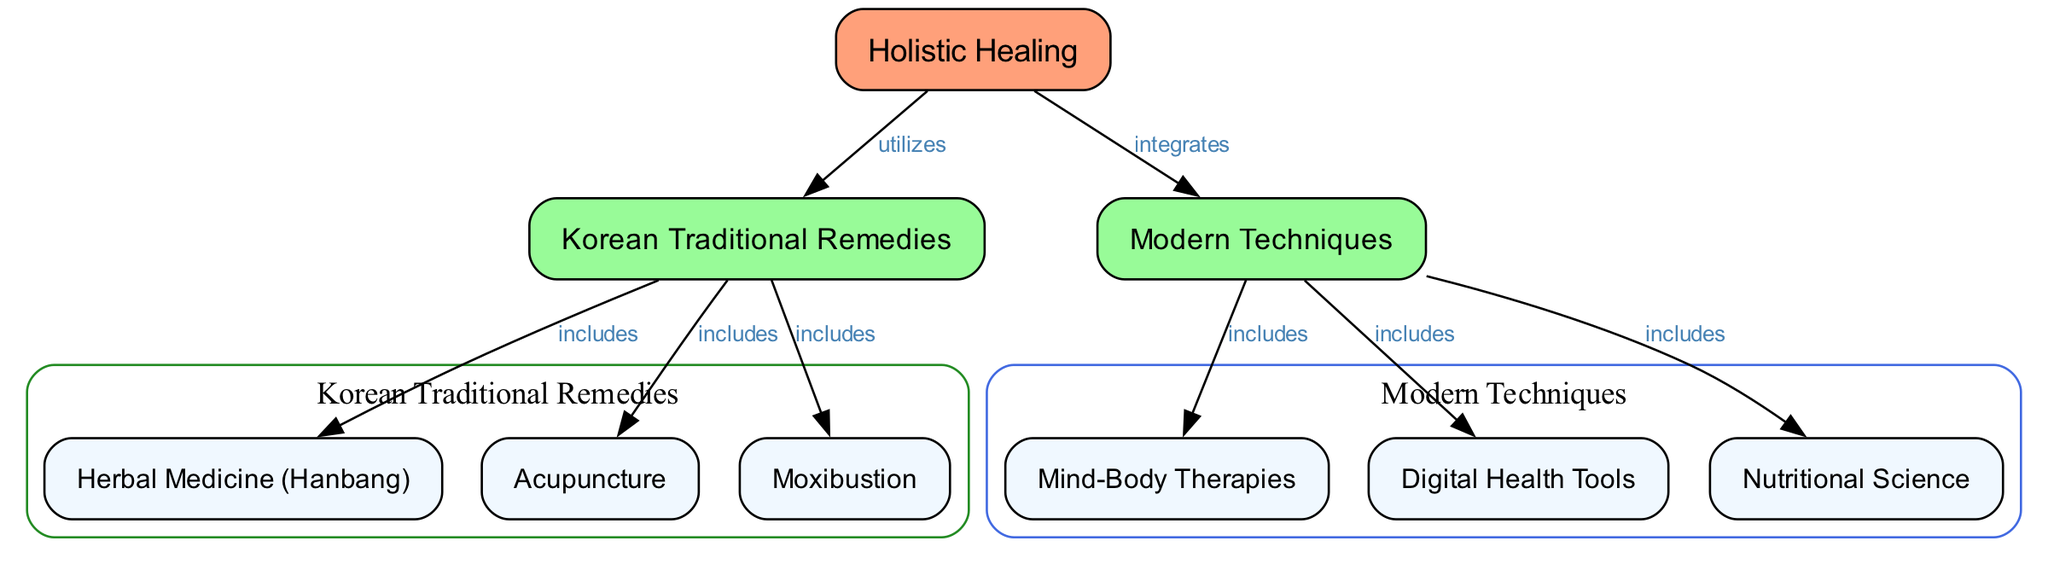What is the main title of the diagram? The title of the diagram is specified as "Holistic Healing Practices: Integrating Korean Traditional Remedies with Modern Techniques," which can be observed at the top of the diagram.
Answer: Holistic Healing Practices: Integrating Korean Traditional Remedies with Modern Techniques How many nodes are present in the diagram? By counting the unique labeled elements in the diagram, there are a total of 9 nodes listed under the "nodes" section.
Answer: 9 What does "Holistic Healing" integrate with? The edges show a relationship where "Holistic Healing" is connected to "Modern Techniques," illustrating that it integrates with modern methods.
Answer: Modern Techniques Which category does "Acupuncture" belong to? The diagram indicates that "Acupuncture" is included within the grouping labeled "Korean Traditional Remedies," which demonstrates its category placement.
Answer: Korean Traditional Remedies What does "Herbal Medicine (Hanbang)" do in relation to "Holistic Healing"? The diagram shows that "Holistic Healing" utilizes "Herbal Medicine (Hanbang)," indicating its supportive role in the practice.
Answer: utilizes What are the three components included in "Modern Techniques"? The diagram lists "Mind-Body Therapies," "Digital Health Tools," and "Nutritional Science" under "Modern Techniques," highlighting these specific practices.
Answer: Mind-Body Therapies, Digital Health Tools, Nutritional Science How many connections does "Korean Traditional Remedies" have? By examining the edges linked to "Korean Traditional Remedies," there are three connections, showing the inclusion of various traditional remedies.
Answer: 3 Which technique is used alongside "Nutritional Science"? The diagram illustrates that "Nutritional Science" is one of the components linked to "Modern Techniques," showcasing its use in conjunction with other modern approaches.
Answer: Modern Techniques What is the relationship between "Herbal Medicine (Hanbang)" and "Korean Traditional Remedies"? The edge indicates that "Herbal Medicine (Hanbang)" is included within the category of "Korean Traditional Remedies," specifying their connection.
Answer: includes What is the color representing "Korean Traditional Remedies" in the diagram? The diagram uses green coloration to denote the group "Korean Traditional Remedies," which is visually represented through the edges and node colors.
Answer: green 